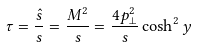<formula> <loc_0><loc_0><loc_500><loc_500>\tau = \frac { \hat { s } } { s } = \frac { M ^ { 2 } } { s } = \frac { 4 p _ { \perp } ^ { 2 } } { s } \cosh ^ { 2 } y</formula> 